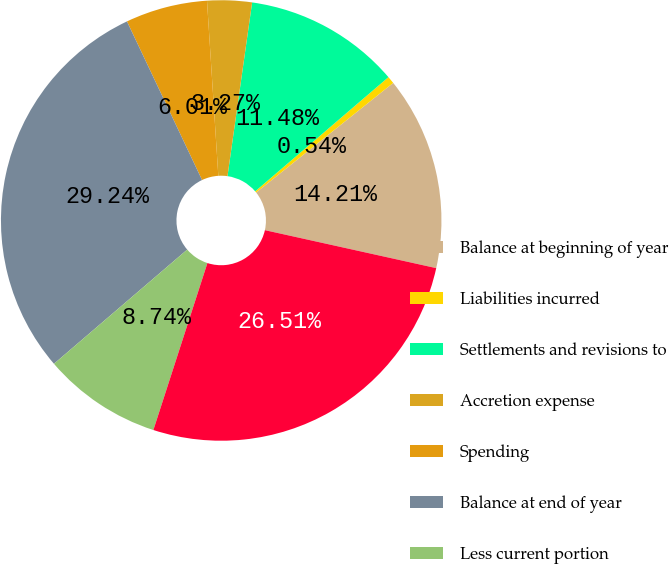Convert chart to OTSL. <chart><loc_0><loc_0><loc_500><loc_500><pie_chart><fcel>Balance at beginning of year<fcel>Liabilities incurred<fcel>Settlements and revisions to<fcel>Accretion expense<fcel>Spending<fcel>Balance at end of year<fcel>Less current portion<fcel>Long-term portion<nl><fcel>14.21%<fcel>0.54%<fcel>11.48%<fcel>3.27%<fcel>6.01%<fcel>29.24%<fcel>8.74%<fcel>26.51%<nl></chart> 